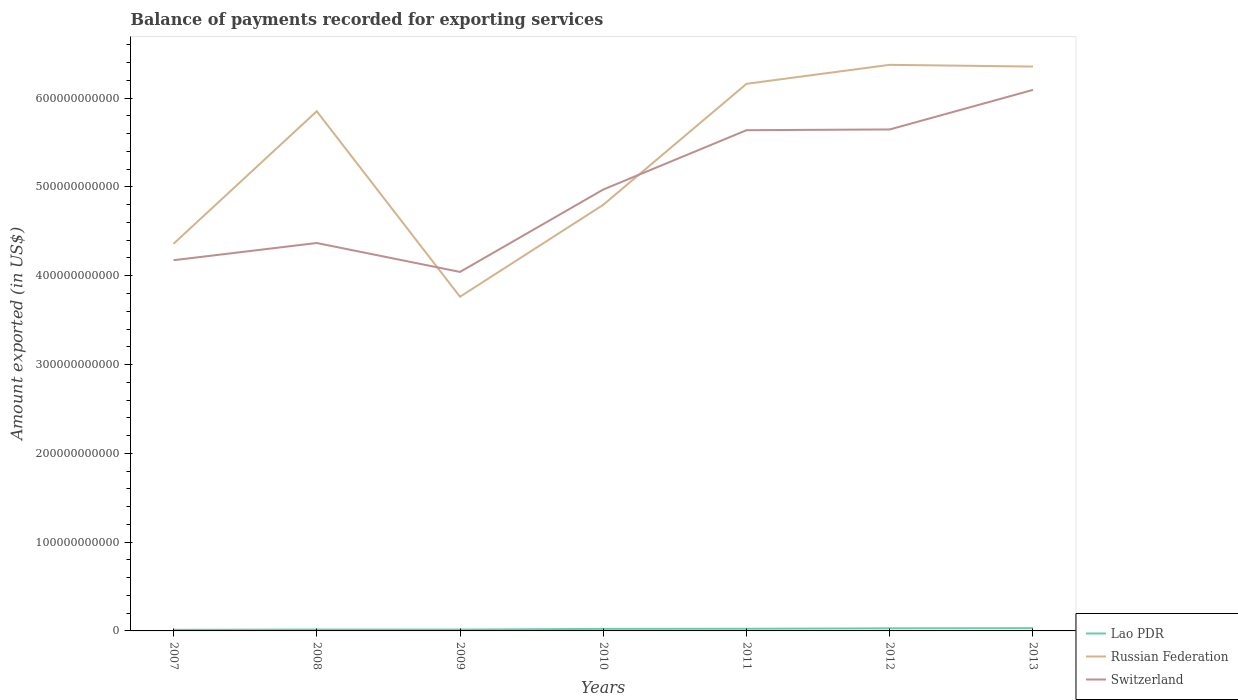How many different coloured lines are there?
Your answer should be compact. 3. Does the line corresponding to Russian Federation intersect with the line corresponding to Switzerland?
Ensure brevity in your answer.  Yes. Is the number of lines equal to the number of legend labels?
Offer a terse response. Yes. Across all years, what is the maximum amount exported in Lao PDR?
Your answer should be very brief. 1.24e+09. What is the total amount exported in Switzerland in the graph?
Provide a short and direct response. -6.77e+1. What is the difference between the highest and the second highest amount exported in Russian Federation?
Keep it short and to the point. 2.61e+11. What is the difference between the highest and the lowest amount exported in Russian Federation?
Offer a terse response. 4. How many lines are there?
Give a very brief answer. 3. How many years are there in the graph?
Offer a terse response. 7. What is the difference between two consecutive major ticks on the Y-axis?
Ensure brevity in your answer.  1.00e+11. Where does the legend appear in the graph?
Your response must be concise. Bottom right. How many legend labels are there?
Offer a terse response. 3. What is the title of the graph?
Offer a very short reply. Balance of payments recorded for exporting services. What is the label or title of the X-axis?
Ensure brevity in your answer.  Years. What is the label or title of the Y-axis?
Keep it short and to the point. Amount exported (in US$). What is the Amount exported (in US$) of Lao PDR in 2007?
Offer a terse response. 1.24e+09. What is the Amount exported (in US$) of Russian Federation in 2007?
Your answer should be compact. 4.36e+11. What is the Amount exported (in US$) of Switzerland in 2007?
Provide a short and direct response. 4.17e+11. What is the Amount exported (in US$) in Lao PDR in 2008?
Your answer should be very brief. 1.53e+09. What is the Amount exported (in US$) in Russian Federation in 2008?
Provide a succinct answer. 5.85e+11. What is the Amount exported (in US$) of Switzerland in 2008?
Your response must be concise. 4.37e+11. What is the Amount exported (in US$) of Lao PDR in 2009?
Offer a very short reply. 1.49e+09. What is the Amount exported (in US$) of Russian Federation in 2009?
Ensure brevity in your answer.  3.76e+11. What is the Amount exported (in US$) in Switzerland in 2009?
Your response must be concise. 4.04e+11. What is the Amount exported (in US$) of Lao PDR in 2010?
Offer a terse response. 2.31e+09. What is the Amount exported (in US$) in Russian Federation in 2010?
Keep it short and to the point. 4.80e+11. What is the Amount exported (in US$) of Switzerland in 2010?
Make the answer very short. 4.97e+11. What is the Amount exported (in US$) of Lao PDR in 2011?
Offer a terse response. 2.45e+09. What is the Amount exported (in US$) of Russian Federation in 2011?
Ensure brevity in your answer.  6.16e+11. What is the Amount exported (in US$) in Switzerland in 2011?
Give a very brief answer. 5.64e+11. What is the Amount exported (in US$) of Lao PDR in 2012?
Give a very brief answer. 2.92e+09. What is the Amount exported (in US$) of Russian Federation in 2012?
Offer a terse response. 6.38e+11. What is the Amount exported (in US$) of Switzerland in 2012?
Your answer should be compact. 5.65e+11. What is the Amount exported (in US$) in Lao PDR in 2013?
Your response must be concise. 3.12e+09. What is the Amount exported (in US$) of Russian Federation in 2013?
Make the answer very short. 6.36e+11. What is the Amount exported (in US$) in Switzerland in 2013?
Ensure brevity in your answer.  6.09e+11. Across all years, what is the maximum Amount exported (in US$) of Lao PDR?
Your answer should be compact. 3.12e+09. Across all years, what is the maximum Amount exported (in US$) of Russian Federation?
Keep it short and to the point. 6.38e+11. Across all years, what is the maximum Amount exported (in US$) in Switzerland?
Keep it short and to the point. 6.09e+11. Across all years, what is the minimum Amount exported (in US$) of Lao PDR?
Offer a terse response. 1.24e+09. Across all years, what is the minimum Amount exported (in US$) of Russian Federation?
Give a very brief answer. 3.76e+11. Across all years, what is the minimum Amount exported (in US$) of Switzerland?
Your response must be concise. 4.04e+11. What is the total Amount exported (in US$) in Lao PDR in the graph?
Ensure brevity in your answer.  1.51e+1. What is the total Amount exported (in US$) in Russian Federation in the graph?
Your answer should be very brief. 3.77e+12. What is the total Amount exported (in US$) of Switzerland in the graph?
Give a very brief answer. 3.49e+12. What is the difference between the Amount exported (in US$) of Lao PDR in 2007 and that in 2008?
Your answer should be very brief. -2.81e+08. What is the difference between the Amount exported (in US$) of Russian Federation in 2007 and that in 2008?
Give a very brief answer. -1.49e+11. What is the difference between the Amount exported (in US$) in Switzerland in 2007 and that in 2008?
Offer a very short reply. -1.94e+1. What is the difference between the Amount exported (in US$) of Lao PDR in 2007 and that in 2009?
Offer a terse response. -2.47e+08. What is the difference between the Amount exported (in US$) of Russian Federation in 2007 and that in 2009?
Provide a short and direct response. 5.96e+1. What is the difference between the Amount exported (in US$) of Switzerland in 2007 and that in 2009?
Make the answer very short. 1.32e+1. What is the difference between the Amount exported (in US$) in Lao PDR in 2007 and that in 2010?
Your answer should be very brief. -1.06e+09. What is the difference between the Amount exported (in US$) of Russian Federation in 2007 and that in 2010?
Give a very brief answer. -4.39e+1. What is the difference between the Amount exported (in US$) of Switzerland in 2007 and that in 2010?
Your answer should be compact. -7.96e+1. What is the difference between the Amount exported (in US$) of Lao PDR in 2007 and that in 2011?
Your response must be concise. -1.21e+09. What is the difference between the Amount exported (in US$) in Russian Federation in 2007 and that in 2011?
Offer a terse response. -1.80e+11. What is the difference between the Amount exported (in US$) of Switzerland in 2007 and that in 2011?
Give a very brief answer. -1.46e+11. What is the difference between the Amount exported (in US$) of Lao PDR in 2007 and that in 2012?
Offer a terse response. -1.67e+09. What is the difference between the Amount exported (in US$) of Russian Federation in 2007 and that in 2012?
Offer a terse response. -2.02e+11. What is the difference between the Amount exported (in US$) in Switzerland in 2007 and that in 2012?
Your answer should be very brief. -1.47e+11. What is the difference between the Amount exported (in US$) of Lao PDR in 2007 and that in 2013?
Offer a very short reply. -1.87e+09. What is the difference between the Amount exported (in US$) in Russian Federation in 2007 and that in 2013?
Make the answer very short. -2.00e+11. What is the difference between the Amount exported (in US$) of Switzerland in 2007 and that in 2013?
Ensure brevity in your answer.  -1.92e+11. What is the difference between the Amount exported (in US$) of Lao PDR in 2008 and that in 2009?
Offer a very short reply. 3.39e+07. What is the difference between the Amount exported (in US$) in Russian Federation in 2008 and that in 2009?
Make the answer very short. 2.09e+11. What is the difference between the Amount exported (in US$) of Switzerland in 2008 and that in 2009?
Make the answer very short. 3.26e+1. What is the difference between the Amount exported (in US$) of Lao PDR in 2008 and that in 2010?
Make the answer very short. -7.82e+08. What is the difference between the Amount exported (in US$) in Russian Federation in 2008 and that in 2010?
Offer a very short reply. 1.05e+11. What is the difference between the Amount exported (in US$) in Switzerland in 2008 and that in 2010?
Your answer should be very brief. -6.02e+1. What is the difference between the Amount exported (in US$) of Lao PDR in 2008 and that in 2011?
Offer a terse response. -9.26e+08. What is the difference between the Amount exported (in US$) of Russian Federation in 2008 and that in 2011?
Provide a succinct answer. -3.09e+1. What is the difference between the Amount exported (in US$) of Switzerland in 2008 and that in 2011?
Provide a short and direct response. -1.27e+11. What is the difference between the Amount exported (in US$) in Lao PDR in 2008 and that in 2012?
Keep it short and to the point. -1.39e+09. What is the difference between the Amount exported (in US$) in Russian Federation in 2008 and that in 2012?
Your answer should be compact. -5.23e+1. What is the difference between the Amount exported (in US$) of Switzerland in 2008 and that in 2012?
Provide a short and direct response. -1.28e+11. What is the difference between the Amount exported (in US$) of Lao PDR in 2008 and that in 2013?
Your answer should be compact. -1.59e+09. What is the difference between the Amount exported (in US$) in Russian Federation in 2008 and that in 2013?
Offer a terse response. -5.03e+1. What is the difference between the Amount exported (in US$) of Switzerland in 2008 and that in 2013?
Keep it short and to the point. -1.72e+11. What is the difference between the Amount exported (in US$) of Lao PDR in 2009 and that in 2010?
Your answer should be very brief. -8.16e+08. What is the difference between the Amount exported (in US$) of Russian Federation in 2009 and that in 2010?
Provide a succinct answer. -1.04e+11. What is the difference between the Amount exported (in US$) in Switzerland in 2009 and that in 2010?
Your answer should be compact. -9.28e+1. What is the difference between the Amount exported (in US$) in Lao PDR in 2009 and that in 2011?
Offer a terse response. -9.60e+08. What is the difference between the Amount exported (in US$) in Russian Federation in 2009 and that in 2011?
Keep it short and to the point. -2.40e+11. What is the difference between the Amount exported (in US$) of Switzerland in 2009 and that in 2011?
Your response must be concise. -1.60e+11. What is the difference between the Amount exported (in US$) of Lao PDR in 2009 and that in 2012?
Keep it short and to the point. -1.43e+09. What is the difference between the Amount exported (in US$) in Russian Federation in 2009 and that in 2012?
Ensure brevity in your answer.  -2.61e+11. What is the difference between the Amount exported (in US$) of Switzerland in 2009 and that in 2012?
Ensure brevity in your answer.  -1.60e+11. What is the difference between the Amount exported (in US$) in Lao PDR in 2009 and that in 2013?
Offer a terse response. -1.63e+09. What is the difference between the Amount exported (in US$) in Russian Federation in 2009 and that in 2013?
Your answer should be compact. -2.59e+11. What is the difference between the Amount exported (in US$) in Switzerland in 2009 and that in 2013?
Offer a terse response. -2.05e+11. What is the difference between the Amount exported (in US$) in Lao PDR in 2010 and that in 2011?
Offer a very short reply. -1.44e+08. What is the difference between the Amount exported (in US$) in Russian Federation in 2010 and that in 2011?
Make the answer very short. -1.36e+11. What is the difference between the Amount exported (in US$) of Switzerland in 2010 and that in 2011?
Keep it short and to the point. -6.68e+1. What is the difference between the Amount exported (in US$) in Lao PDR in 2010 and that in 2012?
Provide a short and direct response. -6.09e+08. What is the difference between the Amount exported (in US$) in Russian Federation in 2010 and that in 2012?
Provide a short and direct response. -1.58e+11. What is the difference between the Amount exported (in US$) of Switzerland in 2010 and that in 2012?
Offer a terse response. -6.77e+1. What is the difference between the Amount exported (in US$) in Lao PDR in 2010 and that in 2013?
Your answer should be compact. -8.10e+08. What is the difference between the Amount exported (in US$) of Russian Federation in 2010 and that in 2013?
Give a very brief answer. -1.56e+11. What is the difference between the Amount exported (in US$) in Switzerland in 2010 and that in 2013?
Offer a terse response. -1.12e+11. What is the difference between the Amount exported (in US$) in Lao PDR in 2011 and that in 2012?
Provide a succinct answer. -4.65e+08. What is the difference between the Amount exported (in US$) of Russian Federation in 2011 and that in 2012?
Keep it short and to the point. -2.14e+1. What is the difference between the Amount exported (in US$) of Switzerland in 2011 and that in 2012?
Give a very brief answer. -8.21e+08. What is the difference between the Amount exported (in US$) in Lao PDR in 2011 and that in 2013?
Your answer should be very brief. -6.66e+08. What is the difference between the Amount exported (in US$) of Russian Federation in 2011 and that in 2013?
Your answer should be very brief. -1.94e+1. What is the difference between the Amount exported (in US$) in Switzerland in 2011 and that in 2013?
Ensure brevity in your answer.  -4.54e+1. What is the difference between the Amount exported (in US$) in Lao PDR in 2012 and that in 2013?
Your answer should be very brief. -2.01e+08. What is the difference between the Amount exported (in US$) in Russian Federation in 2012 and that in 2013?
Make the answer very short. 1.96e+09. What is the difference between the Amount exported (in US$) of Switzerland in 2012 and that in 2013?
Provide a short and direct response. -4.46e+1. What is the difference between the Amount exported (in US$) of Lao PDR in 2007 and the Amount exported (in US$) of Russian Federation in 2008?
Provide a short and direct response. -5.84e+11. What is the difference between the Amount exported (in US$) in Lao PDR in 2007 and the Amount exported (in US$) in Switzerland in 2008?
Provide a short and direct response. -4.36e+11. What is the difference between the Amount exported (in US$) in Russian Federation in 2007 and the Amount exported (in US$) in Switzerland in 2008?
Ensure brevity in your answer.  -8.91e+08. What is the difference between the Amount exported (in US$) of Lao PDR in 2007 and the Amount exported (in US$) of Russian Federation in 2009?
Your answer should be compact. -3.75e+11. What is the difference between the Amount exported (in US$) in Lao PDR in 2007 and the Amount exported (in US$) in Switzerland in 2009?
Provide a short and direct response. -4.03e+11. What is the difference between the Amount exported (in US$) in Russian Federation in 2007 and the Amount exported (in US$) in Switzerland in 2009?
Provide a short and direct response. 3.17e+1. What is the difference between the Amount exported (in US$) of Lao PDR in 2007 and the Amount exported (in US$) of Russian Federation in 2010?
Make the answer very short. -4.79e+11. What is the difference between the Amount exported (in US$) in Lao PDR in 2007 and the Amount exported (in US$) in Switzerland in 2010?
Ensure brevity in your answer.  -4.96e+11. What is the difference between the Amount exported (in US$) in Russian Federation in 2007 and the Amount exported (in US$) in Switzerland in 2010?
Your answer should be compact. -6.11e+1. What is the difference between the Amount exported (in US$) of Lao PDR in 2007 and the Amount exported (in US$) of Russian Federation in 2011?
Offer a very short reply. -6.15e+11. What is the difference between the Amount exported (in US$) of Lao PDR in 2007 and the Amount exported (in US$) of Switzerland in 2011?
Offer a terse response. -5.63e+11. What is the difference between the Amount exported (in US$) in Russian Federation in 2007 and the Amount exported (in US$) in Switzerland in 2011?
Offer a terse response. -1.28e+11. What is the difference between the Amount exported (in US$) of Lao PDR in 2007 and the Amount exported (in US$) of Russian Federation in 2012?
Provide a short and direct response. -6.36e+11. What is the difference between the Amount exported (in US$) of Lao PDR in 2007 and the Amount exported (in US$) of Switzerland in 2012?
Your response must be concise. -5.64e+11. What is the difference between the Amount exported (in US$) in Russian Federation in 2007 and the Amount exported (in US$) in Switzerland in 2012?
Ensure brevity in your answer.  -1.29e+11. What is the difference between the Amount exported (in US$) in Lao PDR in 2007 and the Amount exported (in US$) in Russian Federation in 2013?
Give a very brief answer. -6.34e+11. What is the difference between the Amount exported (in US$) of Lao PDR in 2007 and the Amount exported (in US$) of Switzerland in 2013?
Offer a very short reply. -6.08e+11. What is the difference between the Amount exported (in US$) of Russian Federation in 2007 and the Amount exported (in US$) of Switzerland in 2013?
Provide a short and direct response. -1.73e+11. What is the difference between the Amount exported (in US$) of Lao PDR in 2008 and the Amount exported (in US$) of Russian Federation in 2009?
Make the answer very short. -3.75e+11. What is the difference between the Amount exported (in US$) of Lao PDR in 2008 and the Amount exported (in US$) of Switzerland in 2009?
Offer a very short reply. -4.03e+11. What is the difference between the Amount exported (in US$) in Russian Federation in 2008 and the Amount exported (in US$) in Switzerland in 2009?
Keep it short and to the point. 1.81e+11. What is the difference between the Amount exported (in US$) of Lao PDR in 2008 and the Amount exported (in US$) of Russian Federation in 2010?
Your answer should be very brief. -4.78e+11. What is the difference between the Amount exported (in US$) in Lao PDR in 2008 and the Amount exported (in US$) in Switzerland in 2010?
Provide a short and direct response. -4.96e+11. What is the difference between the Amount exported (in US$) in Russian Federation in 2008 and the Amount exported (in US$) in Switzerland in 2010?
Provide a succinct answer. 8.82e+1. What is the difference between the Amount exported (in US$) in Lao PDR in 2008 and the Amount exported (in US$) in Russian Federation in 2011?
Your answer should be very brief. -6.15e+11. What is the difference between the Amount exported (in US$) of Lao PDR in 2008 and the Amount exported (in US$) of Switzerland in 2011?
Provide a succinct answer. -5.62e+11. What is the difference between the Amount exported (in US$) of Russian Federation in 2008 and the Amount exported (in US$) of Switzerland in 2011?
Provide a succinct answer. 2.13e+1. What is the difference between the Amount exported (in US$) of Lao PDR in 2008 and the Amount exported (in US$) of Russian Federation in 2012?
Provide a succinct answer. -6.36e+11. What is the difference between the Amount exported (in US$) of Lao PDR in 2008 and the Amount exported (in US$) of Switzerland in 2012?
Ensure brevity in your answer.  -5.63e+11. What is the difference between the Amount exported (in US$) in Russian Federation in 2008 and the Amount exported (in US$) in Switzerland in 2012?
Make the answer very short. 2.05e+1. What is the difference between the Amount exported (in US$) of Lao PDR in 2008 and the Amount exported (in US$) of Russian Federation in 2013?
Keep it short and to the point. -6.34e+11. What is the difference between the Amount exported (in US$) in Lao PDR in 2008 and the Amount exported (in US$) in Switzerland in 2013?
Ensure brevity in your answer.  -6.08e+11. What is the difference between the Amount exported (in US$) of Russian Federation in 2008 and the Amount exported (in US$) of Switzerland in 2013?
Make the answer very short. -2.41e+1. What is the difference between the Amount exported (in US$) in Lao PDR in 2009 and the Amount exported (in US$) in Russian Federation in 2010?
Provide a succinct answer. -4.78e+11. What is the difference between the Amount exported (in US$) of Lao PDR in 2009 and the Amount exported (in US$) of Switzerland in 2010?
Provide a succinct answer. -4.96e+11. What is the difference between the Amount exported (in US$) of Russian Federation in 2009 and the Amount exported (in US$) of Switzerland in 2010?
Make the answer very short. -1.21e+11. What is the difference between the Amount exported (in US$) of Lao PDR in 2009 and the Amount exported (in US$) of Russian Federation in 2011?
Your response must be concise. -6.15e+11. What is the difference between the Amount exported (in US$) in Lao PDR in 2009 and the Amount exported (in US$) in Switzerland in 2011?
Make the answer very short. -5.62e+11. What is the difference between the Amount exported (in US$) of Russian Federation in 2009 and the Amount exported (in US$) of Switzerland in 2011?
Make the answer very short. -1.88e+11. What is the difference between the Amount exported (in US$) of Lao PDR in 2009 and the Amount exported (in US$) of Russian Federation in 2012?
Make the answer very short. -6.36e+11. What is the difference between the Amount exported (in US$) in Lao PDR in 2009 and the Amount exported (in US$) in Switzerland in 2012?
Make the answer very short. -5.63e+11. What is the difference between the Amount exported (in US$) of Russian Federation in 2009 and the Amount exported (in US$) of Switzerland in 2012?
Provide a succinct answer. -1.88e+11. What is the difference between the Amount exported (in US$) in Lao PDR in 2009 and the Amount exported (in US$) in Russian Federation in 2013?
Offer a terse response. -6.34e+11. What is the difference between the Amount exported (in US$) of Lao PDR in 2009 and the Amount exported (in US$) of Switzerland in 2013?
Offer a terse response. -6.08e+11. What is the difference between the Amount exported (in US$) of Russian Federation in 2009 and the Amount exported (in US$) of Switzerland in 2013?
Offer a very short reply. -2.33e+11. What is the difference between the Amount exported (in US$) of Lao PDR in 2010 and the Amount exported (in US$) of Russian Federation in 2011?
Provide a short and direct response. -6.14e+11. What is the difference between the Amount exported (in US$) in Lao PDR in 2010 and the Amount exported (in US$) in Switzerland in 2011?
Ensure brevity in your answer.  -5.62e+11. What is the difference between the Amount exported (in US$) of Russian Federation in 2010 and the Amount exported (in US$) of Switzerland in 2011?
Ensure brevity in your answer.  -8.40e+1. What is the difference between the Amount exported (in US$) in Lao PDR in 2010 and the Amount exported (in US$) in Russian Federation in 2012?
Your response must be concise. -6.35e+11. What is the difference between the Amount exported (in US$) in Lao PDR in 2010 and the Amount exported (in US$) in Switzerland in 2012?
Ensure brevity in your answer.  -5.62e+11. What is the difference between the Amount exported (in US$) of Russian Federation in 2010 and the Amount exported (in US$) of Switzerland in 2012?
Your answer should be very brief. -8.49e+1. What is the difference between the Amount exported (in US$) in Lao PDR in 2010 and the Amount exported (in US$) in Russian Federation in 2013?
Ensure brevity in your answer.  -6.33e+11. What is the difference between the Amount exported (in US$) in Lao PDR in 2010 and the Amount exported (in US$) in Switzerland in 2013?
Your answer should be very brief. -6.07e+11. What is the difference between the Amount exported (in US$) of Russian Federation in 2010 and the Amount exported (in US$) of Switzerland in 2013?
Your answer should be very brief. -1.29e+11. What is the difference between the Amount exported (in US$) in Lao PDR in 2011 and the Amount exported (in US$) in Russian Federation in 2012?
Your answer should be compact. -6.35e+11. What is the difference between the Amount exported (in US$) in Lao PDR in 2011 and the Amount exported (in US$) in Switzerland in 2012?
Ensure brevity in your answer.  -5.62e+11. What is the difference between the Amount exported (in US$) in Russian Federation in 2011 and the Amount exported (in US$) in Switzerland in 2012?
Ensure brevity in your answer.  5.14e+1. What is the difference between the Amount exported (in US$) of Lao PDR in 2011 and the Amount exported (in US$) of Russian Federation in 2013?
Your answer should be compact. -6.33e+11. What is the difference between the Amount exported (in US$) in Lao PDR in 2011 and the Amount exported (in US$) in Switzerland in 2013?
Your answer should be very brief. -6.07e+11. What is the difference between the Amount exported (in US$) of Russian Federation in 2011 and the Amount exported (in US$) of Switzerland in 2013?
Provide a short and direct response. 6.81e+09. What is the difference between the Amount exported (in US$) in Lao PDR in 2012 and the Amount exported (in US$) in Russian Federation in 2013?
Your answer should be very brief. -6.33e+11. What is the difference between the Amount exported (in US$) of Lao PDR in 2012 and the Amount exported (in US$) of Switzerland in 2013?
Your answer should be compact. -6.06e+11. What is the difference between the Amount exported (in US$) of Russian Federation in 2012 and the Amount exported (in US$) of Switzerland in 2013?
Provide a short and direct response. 2.82e+1. What is the average Amount exported (in US$) of Lao PDR per year?
Your answer should be very brief. 2.15e+09. What is the average Amount exported (in US$) of Russian Federation per year?
Your answer should be very brief. 5.38e+11. What is the average Amount exported (in US$) of Switzerland per year?
Provide a succinct answer. 4.99e+11. In the year 2007, what is the difference between the Amount exported (in US$) of Lao PDR and Amount exported (in US$) of Russian Federation?
Make the answer very short. -4.35e+11. In the year 2007, what is the difference between the Amount exported (in US$) in Lao PDR and Amount exported (in US$) in Switzerland?
Provide a succinct answer. -4.16e+11. In the year 2007, what is the difference between the Amount exported (in US$) in Russian Federation and Amount exported (in US$) in Switzerland?
Make the answer very short. 1.85e+1. In the year 2008, what is the difference between the Amount exported (in US$) in Lao PDR and Amount exported (in US$) in Russian Federation?
Your response must be concise. -5.84e+11. In the year 2008, what is the difference between the Amount exported (in US$) in Lao PDR and Amount exported (in US$) in Switzerland?
Offer a very short reply. -4.35e+11. In the year 2008, what is the difference between the Amount exported (in US$) in Russian Federation and Amount exported (in US$) in Switzerland?
Provide a short and direct response. 1.48e+11. In the year 2009, what is the difference between the Amount exported (in US$) in Lao PDR and Amount exported (in US$) in Russian Federation?
Your answer should be very brief. -3.75e+11. In the year 2009, what is the difference between the Amount exported (in US$) of Lao PDR and Amount exported (in US$) of Switzerland?
Offer a terse response. -4.03e+11. In the year 2009, what is the difference between the Amount exported (in US$) of Russian Federation and Amount exported (in US$) of Switzerland?
Make the answer very short. -2.79e+1. In the year 2010, what is the difference between the Amount exported (in US$) of Lao PDR and Amount exported (in US$) of Russian Federation?
Give a very brief answer. -4.78e+11. In the year 2010, what is the difference between the Amount exported (in US$) in Lao PDR and Amount exported (in US$) in Switzerland?
Your response must be concise. -4.95e+11. In the year 2010, what is the difference between the Amount exported (in US$) in Russian Federation and Amount exported (in US$) in Switzerland?
Ensure brevity in your answer.  -1.72e+1. In the year 2011, what is the difference between the Amount exported (in US$) in Lao PDR and Amount exported (in US$) in Russian Federation?
Make the answer very short. -6.14e+11. In the year 2011, what is the difference between the Amount exported (in US$) of Lao PDR and Amount exported (in US$) of Switzerland?
Offer a terse response. -5.61e+11. In the year 2011, what is the difference between the Amount exported (in US$) of Russian Federation and Amount exported (in US$) of Switzerland?
Provide a succinct answer. 5.22e+1. In the year 2012, what is the difference between the Amount exported (in US$) in Lao PDR and Amount exported (in US$) in Russian Federation?
Keep it short and to the point. -6.35e+11. In the year 2012, what is the difference between the Amount exported (in US$) of Lao PDR and Amount exported (in US$) of Switzerland?
Your response must be concise. -5.62e+11. In the year 2012, what is the difference between the Amount exported (in US$) of Russian Federation and Amount exported (in US$) of Switzerland?
Make the answer very short. 7.28e+1. In the year 2013, what is the difference between the Amount exported (in US$) in Lao PDR and Amount exported (in US$) in Russian Federation?
Give a very brief answer. -6.32e+11. In the year 2013, what is the difference between the Amount exported (in US$) of Lao PDR and Amount exported (in US$) of Switzerland?
Provide a short and direct response. -6.06e+11. In the year 2013, what is the difference between the Amount exported (in US$) of Russian Federation and Amount exported (in US$) of Switzerland?
Make the answer very short. 2.63e+1. What is the ratio of the Amount exported (in US$) in Lao PDR in 2007 to that in 2008?
Your answer should be compact. 0.82. What is the ratio of the Amount exported (in US$) of Russian Federation in 2007 to that in 2008?
Give a very brief answer. 0.74. What is the ratio of the Amount exported (in US$) in Switzerland in 2007 to that in 2008?
Provide a short and direct response. 0.96. What is the ratio of the Amount exported (in US$) of Lao PDR in 2007 to that in 2009?
Provide a short and direct response. 0.83. What is the ratio of the Amount exported (in US$) in Russian Federation in 2007 to that in 2009?
Give a very brief answer. 1.16. What is the ratio of the Amount exported (in US$) in Switzerland in 2007 to that in 2009?
Offer a terse response. 1.03. What is the ratio of the Amount exported (in US$) of Lao PDR in 2007 to that in 2010?
Keep it short and to the point. 0.54. What is the ratio of the Amount exported (in US$) of Russian Federation in 2007 to that in 2010?
Keep it short and to the point. 0.91. What is the ratio of the Amount exported (in US$) in Switzerland in 2007 to that in 2010?
Provide a succinct answer. 0.84. What is the ratio of the Amount exported (in US$) in Lao PDR in 2007 to that in 2011?
Your answer should be compact. 0.51. What is the ratio of the Amount exported (in US$) in Russian Federation in 2007 to that in 2011?
Make the answer very short. 0.71. What is the ratio of the Amount exported (in US$) in Switzerland in 2007 to that in 2011?
Your response must be concise. 0.74. What is the ratio of the Amount exported (in US$) in Lao PDR in 2007 to that in 2012?
Ensure brevity in your answer.  0.43. What is the ratio of the Amount exported (in US$) in Russian Federation in 2007 to that in 2012?
Your answer should be compact. 0.68. What is the ratio of the Amount exported (in US$) of Switzerland in 2007 to that in 2012?
Give a very brief answer. 0.74. What is the ratio of the Amount exported (in US$) in Lao PDR in 2007 to that in 2013?
Make the answer very short. 0.4. What is the ratio of the Amount exported (in US$) of Russian Federation in 2007 to that in 2013?
Give a very brief answer. 0.69. What is the ratio of the Amount exported (in US$) in Switzerland in 2007 to that in 2013?
Keep it short and to the point. 0.69. What is the ratio of the Amount exported (in US$) of Lao PDR in 2008 to that in 2009?
Your answer should be compact. 1.02. What is the ratio of the Amount exported (in US$) of Russian Federation in 2008 to that in 2009?
Give a very brief answer. 1.56. What is the ratio of the Amount exported (in US$) of Switzerland in 2008 to that in 2009?
Give a very brief answer. 1.08. What is the ratio of the Amount exported (in US$) in Lao PDR in 2008 to that in 2010?
Your answer should be compact. 0.66. What is the ratio of the Amount exported (in US$) of Russian Federation in 2008 to that in 2010?
Offer a terse response. 1.22. What is the ratio of the Amount exported (in US$) in Switzerland in 2008 to that in 2010?
Offer a terse response. 0.88. What is the ratio of the Amount exported (in US$) in Lao PDR in 2008 to that in 2011?
Offer a terse response. 0.62. What is the ratio of the Amount exported (in US$) of Russian Federation in 2008 to that in 2011?
Keep it short and to the point. 0.95. What is the ratio of the Amount exported (in US$) of Switzerland in 2008 to that in 2011?
Provide a succinct answer. 0.77. What is the ratio of the Amount exported (in US$) of Lao PDR in 2008 to that in 2012?
Your answer should be compact. 0.52. What is the ratio of the Amount exported (in US$) in Russian Federation in 2008 to that in 2012?
Give a very brief answer. 0.92. What is the ratio of the Amount exported (in US$) in Switzerland in 2008 to that in 2012?
Provide a short and direct response. 0.77. What is the ratio of the Amount exported (in US$) of Lao PDR in 2008 to that in 2013?
Keep it short and to the point. 0.49. What is the ratio of the Amount exported (in US$) in Russian Federation in 2008 to that in 2013?
Keep it short and to the point. 0.92. What is the ratio of the Amount exported (in US$) of Switzerland in 2008 to that in 2013?
Your response must be concise. 0.72. What is the ratio of the Amount exported (in US$) in Lao PDR in 2009 to that in 2010?
Your answer should be very brief. 0.65. What is the ratio of the Amount exported (in US$) of Russian Federation in 2009 to that in 2010?
Your answer should be compact. 0.78. What is the ratio of the Amount exported (in US$) in Switzerland in 2009 to that in 2010?
Provide a succinct answer. 0.81. What is the ratio of the Amount exported (in US$) in Lao PDR in 2009 to that in 2011?
Make the answer very short. 0.61. What is the ratio of the Amount exported (in US$) of Russian Federation in 2009 to that in 2011?
Make the answer very short. 0.61. What is the ratio of the Amount exported (in US$) of Switzerland in 2009 to that in 2011?
Your answer should be very brief. 0.72. What is the ratio of the Amount exported (in US$) of Lao PDR in 2009 to that in 2012?
Offer a very short reply. 0.51. What is the ratio of the Amount exported (in US$) of Russian Federation in 2009 to that in 2012?
Give a very brief answer. 0.59. What is the ratio of the Amount exported (in US$) in Switzerland in 2009 to that in 2012?
Ensure brevity in your answer.  0.72. What is the ratio of the Amount exported (in US$) of Lao PDR in 2009 to that in 2013?
Your answer should be very brief. 0.48. What is the ratio of the Amount exported (in US$) of Russian Federation in 2009 to that in 2013?
Give a very brief answer. 0.59. What is the ratio of the Amount exported (in US$) in Switzerland in 2009 to that in 2013?
Keep it short and to the point. 0.66. What is the ratio of the Amount exported (in US$) in Lao PDR in 2010 to that in 2011?
Provide a succinct answer. 0.94. What is the ratio of the Amount exported (in US$) of Russian Federation in 2010 to that in 2011?
Ensure brevity in your answer.  0.78. What is the ratio of the Amount exported (in US$) of Switzerland in 2010 to that in 2011?
Make the answer very short. 0.88. What is the ratio of the Amount exported (in US$) of Lao PDR in 2010 to that in 2012?
Ensure brevity in your answer.  0.79. What is the ratio of the Amount exported (in US$) of Russian Federation in 2010 to that in 2012?
Provide a short and direct response. 0.75. What is the ratio of the Amount exported (in US$) in Switzerland in 2010 to that in 2012?
Offer a terse response. 0.88. What is the ratio of the Amount exported (in US$) of Lao PDR in 2010 to that in 2013?
Ensure brevity in your answer.  0.74. What is the ratio of the Amount exported (in US$) of Russian Federation in 2010 to that in 2013?
Your response must be concise. 0.76. What is the ratio of the Amount exported (in US$) of Switzerland in 2010 to that in 2013?
Offer a terse response. 0.82. What is the ratio of the Amount exported (in US$) in Lao PDR in 2011 to that in 2012?
Your response must be concise. 0.84. What is the ratio of the Amount exported (in US$) of Russian Federation in 2011 to that in 2012?
Offer a terse response. 0.97. What is the ratio of the Amount exported (in US$) in Lao PDR in 2011 to that in 2013?
Provide a succinct answer. 0.79. What is the ratio of the Amount exported (in US$) of Russian Federation in 2011 to that in 2013?
Provide a succinct answer. 0.97. What is the ratio of the Amount exported (in US$) in Switzerland in 2011 to that in 2013?
Keep it short and to the point. 0.93. What is the ratio of the Amount exported (in US$) of Lao PDR in 2012 to that in 2013?
Offer a very short reply. 0.94. What is the ratio of the Amount exported (in US$) of Switzerland in 2012 to that in 2013?
Your answer should be very brief. 0.93. What is the difference between the highest and the second highest Amount exported (in US$) in Lao PDR?
Your answer should be very brief. 2.01e+08. What is the difference between the highest and the second highest Amount exported (in US$) in Russian Federation?
Offer a very short reply. 1.96e+09. What is the difference between the highest and the second highest Amount exported (in US$) in Switzerland?
Your answer should be compact. 4.46e+1. What is the difference between the highest and the lowest Amount exported (in US$) in Lao PDR?
Provide a short and direct response. 1.87e+09. What is the difference between the highest and the lowest Amount exported (in US$) of Russian Federation?
Give a very brief answer. 2.61e+11. What is the difference between the highest and the lowest Amount exported (in US$) of Switzerland?
Provide a short and direct response. 2.05e+11. 